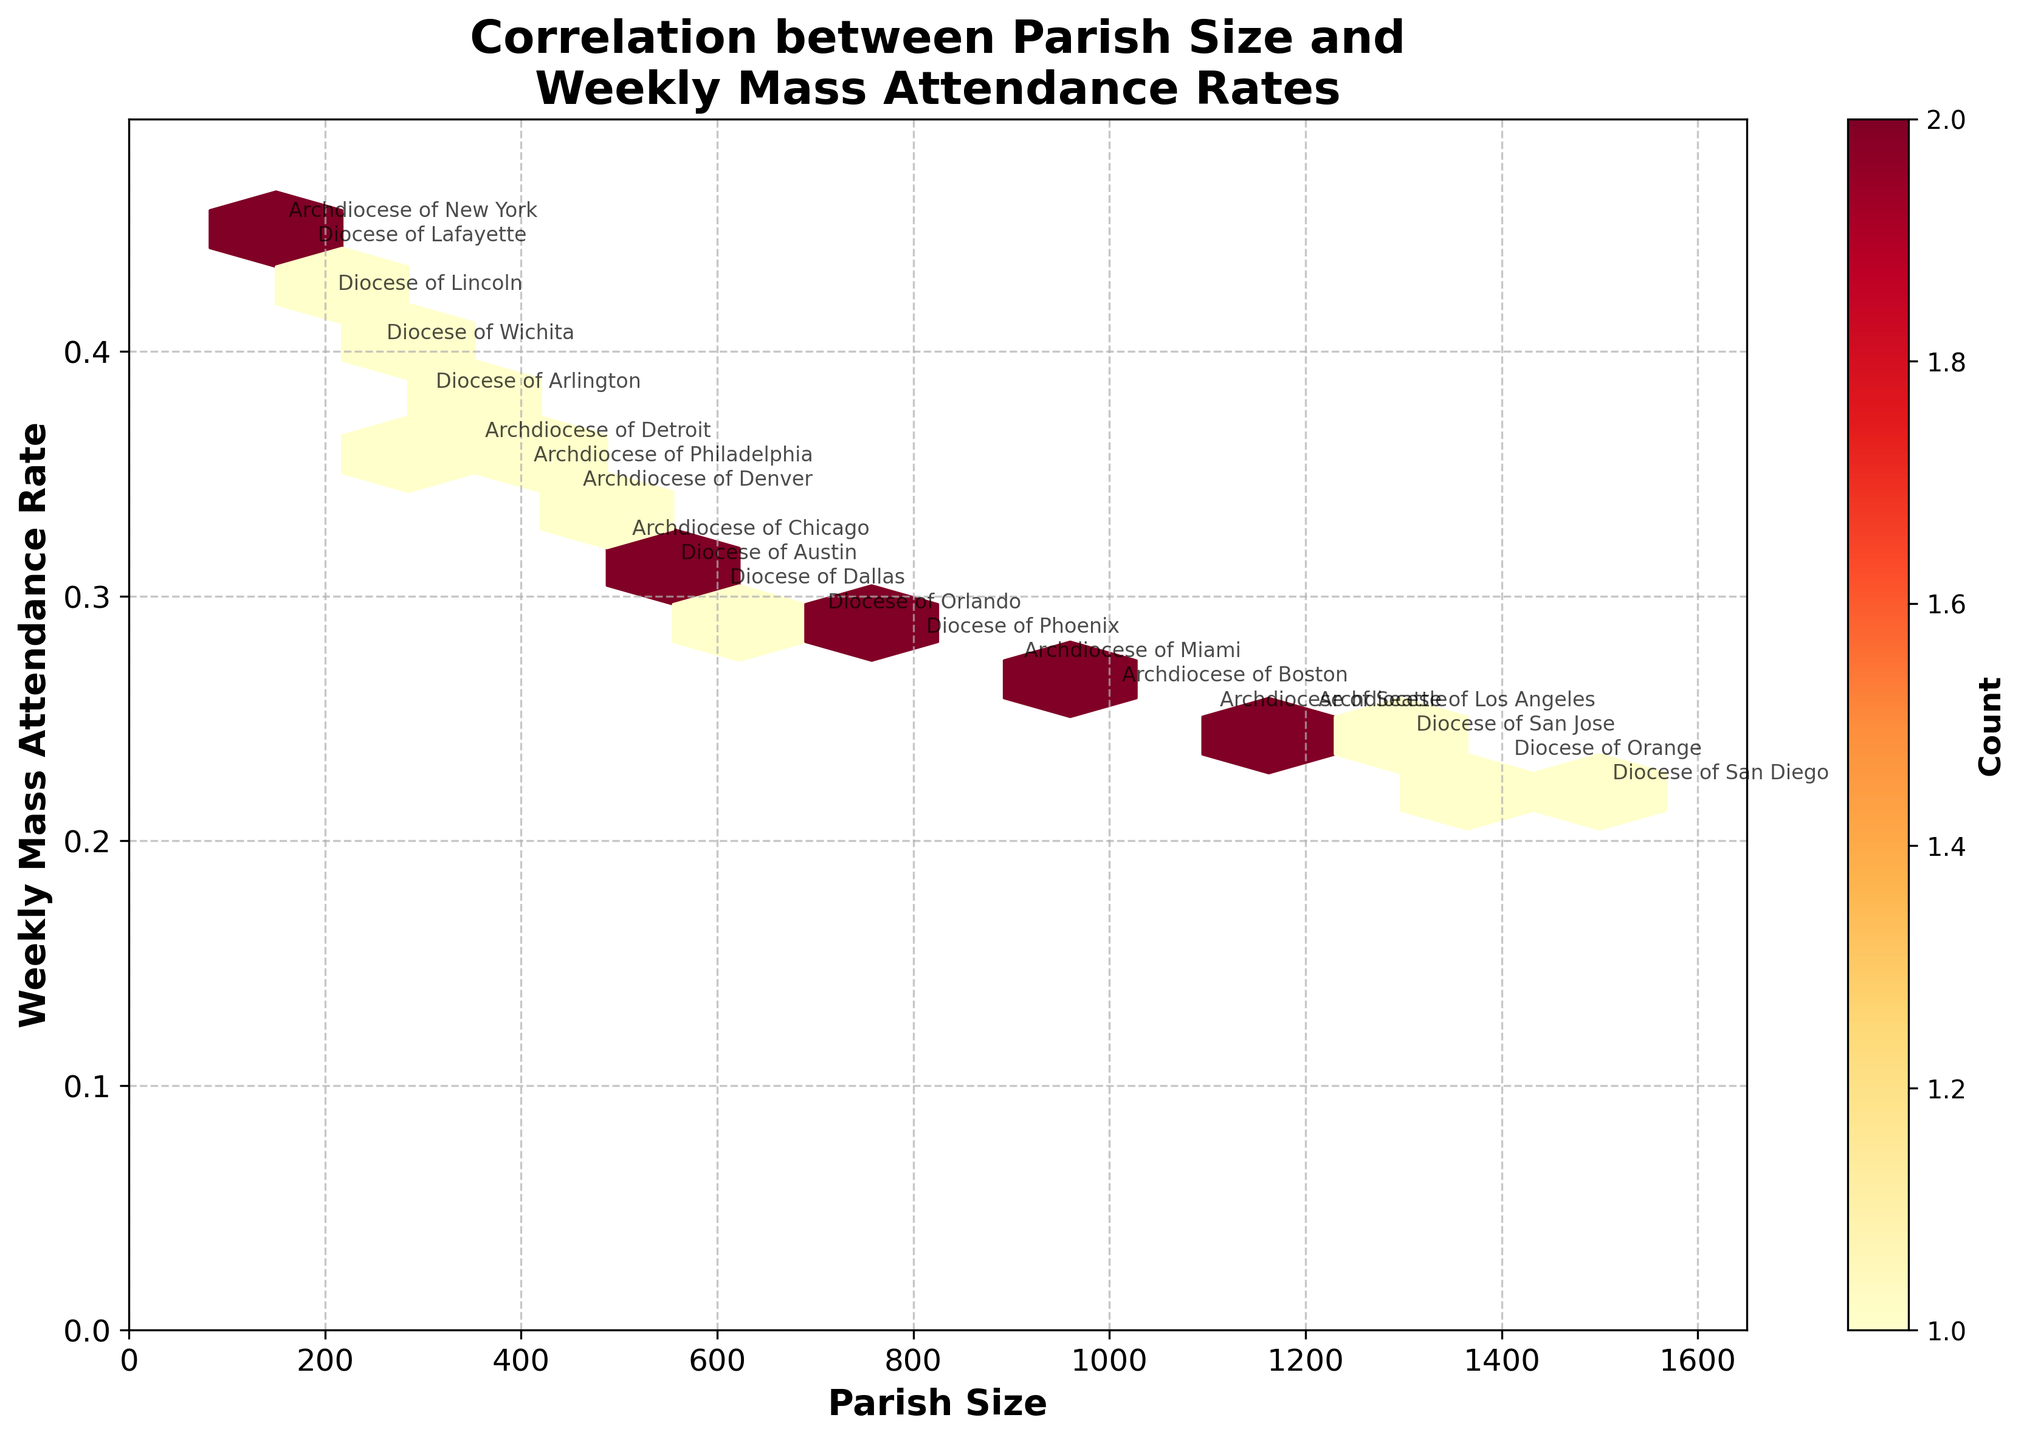What is the title of the plot? The title can be found at the top of the plot. It reads "Correlation between Parish Size and Weekly Mass Attendance Rates."
Answer: Correlation between Parish Size and Weekly Mass Attendance Rates What are the labels of the x and y axes? The x-axis label is visible at the bottom, whereas the y-axis label is on the left side. They read "Parish Size" and "Weekly Mass Attendance Rate," respectively.
Answer: Parish Size and Weekly Mass Attendance Rate What is the parish size of the Archdiocese of New York? Locate the annotation for the "Archdiocese of New York" on the plot. The x-coordinate of this point represents the parish size.
Answer: 150 Which diocese has the lowest weekly Mass attendance rate? Identify the lowest point on the y-axis and find the corresponding annotation. "Diocese of San Diego" is at approximately 0.22, the lowest marked point.
Answer: Diocese of San Diego How many data points are there in the plot? Count the total number of unique annotations representing different dioceses. There are 20 dioceses represented in the plot.
Answer: 20 Is there a general trend between parish size and weekly Mass attendance rate? Observe the densest hexbin areas and the overall distribution. There's a general trend where larger parishes tend to have lower weekly Mass attendance rates.
Answer: Larger parishes tend to have lower attendance rates Which diocese has the largest parish size, and what is its weekly Mass attendance rate? Identify the point with the highest x-coordinate. The annotation shows "Diocese of San Diego" with a parish size of 1500 and an attendance rate of 0.22.
Answer: Diocese of San Diego with an 0.22 rate How are the colors in the plot used to convey information? The color indicates the count of data points within each hexbin. Darker colors (reds) represent higher counts, while lighter colors (yellows) represent fewer counts.
Answer: Darker colors indicate higher counts What is the range of the weekly Mass attendance rates in the plot? Identify the lowest and highest points on the y-axis. The range is from approximately 0.22 to 0.45.
Answer: 0.22 to 0.45 Which dioceses are located in denser areas on the plot? Identify the darker hexbin areas. Dioceses like "Archdiocese of Chicago," "Archdiocese of Los Angeles," and "Diocese of Phoenix" are within these denser regions.
Answer: Archdiocese of Chicago, Archdiocese of Los Angeles, and Diocese of Phoenix 